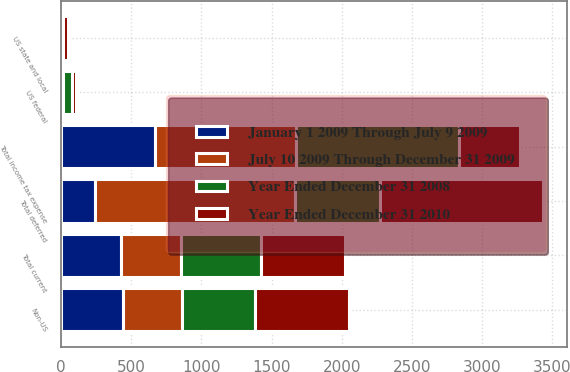Convert chart to OTSL. <chart><loc_0><loc_0><loc_500><loc_500><stacked_bar_chart><ecel><fcel>US federal<fcel>Non-US<fcel>US state and local<fcel>Total current<fcel>Total deferred<fcel>Total income tax expense<nl><fcel>January 1 2009 Through July 9 2009<fcel>10<fcel>441<fcel>1<fcel>430<fcel>242<fcel>672<nl><fcel>July 10 2009 Through December 31 2009<fcel>7<fcel>421<fcel>1<fcel>427<fcel>1427<fcel>1000<nl><fcel>Year Ended December 31 2008<fcel>60<fcel>522<fcel>16<fcel>566<fcel>600<fcel>1166<nl><fcel>Year Ended December 31 2010<fcel>31<fcel>668<fcel>34<fcel>603<fcel>1163<fcel>430<nl></chart> 